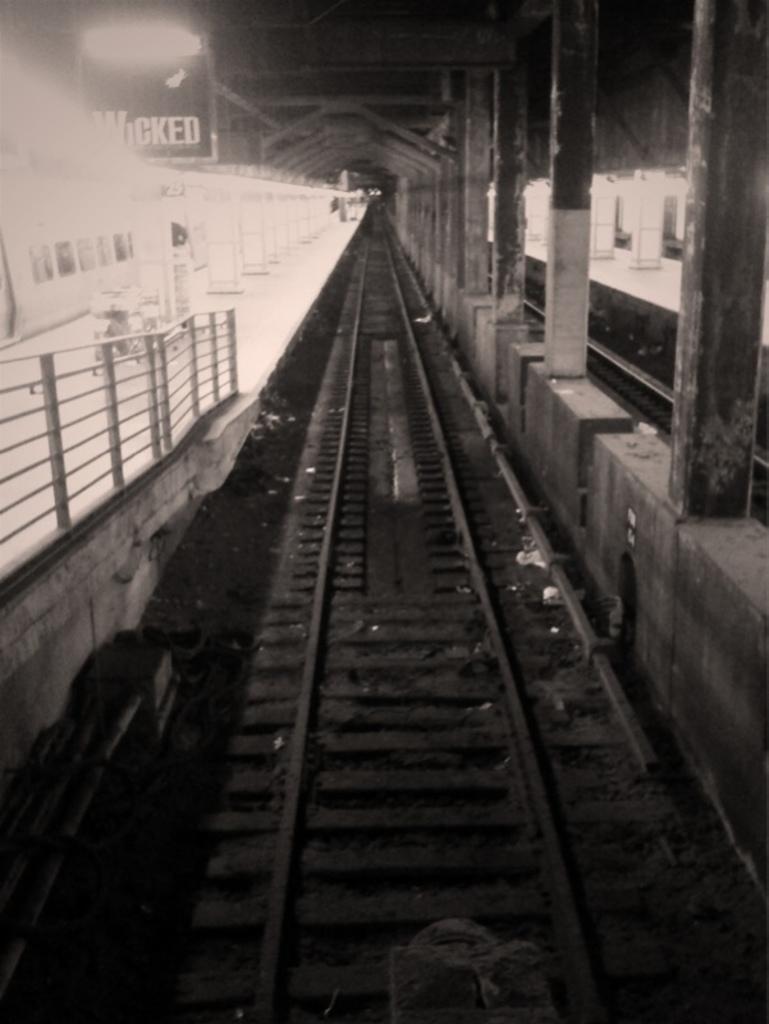Please provide a concise description of this image. In this picture we can see a railway track in the front, on the left side there is a platform, on the right side there are some pillars, we can see a light at the left top of the picture, it is a black and white image. 